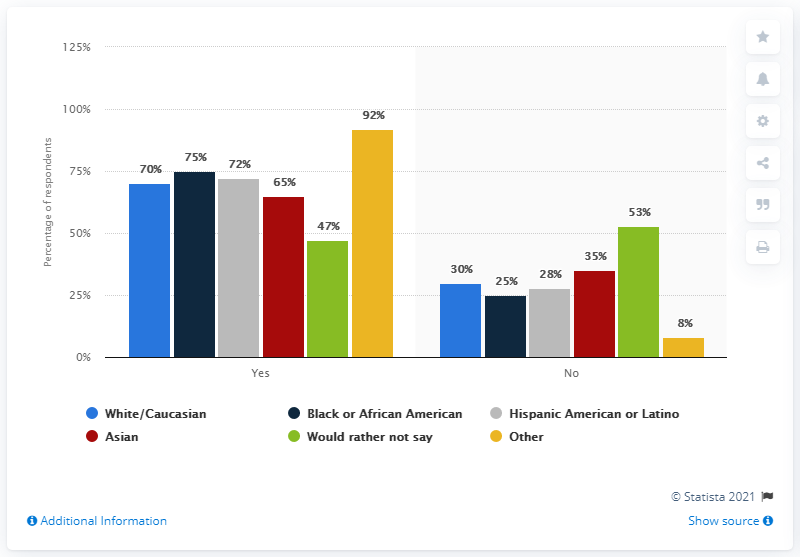Give some essential details in this illustration. In Asia, 65% of yes respondents believe that positive effects will result from the use of technology in the workplace. The sum of the Yes and No percentages of respondents who identify as Black or African American is 100%. 